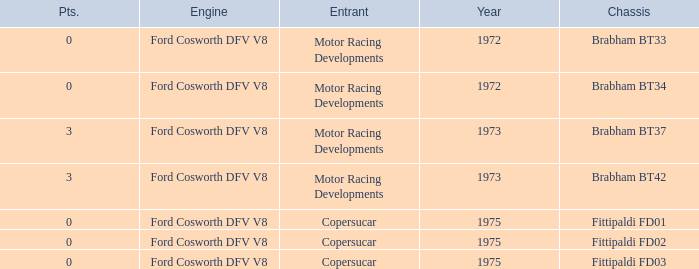Which engine from 1973 has a Brabham bt37 chassis? Ford Cosworth DFV V8. 